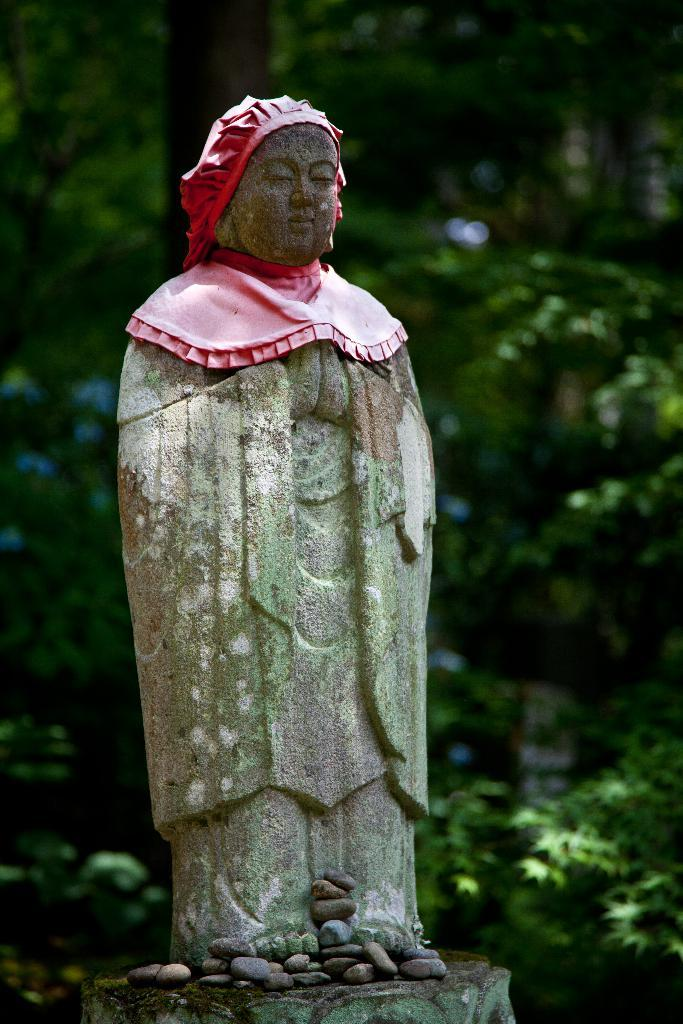What is the main subject in the center of the image? There is a statue in the center of the image. What can be seen at the bottom of the image? There are stones at the bottom of the image. What type of natural scenery is visible in the background of the image? There are trees visible in the background of the image. What type of screw is used to hold the statue together in the image? There is no screw visible in the image, and the statue's construction is not mentioned in the provided facts. 